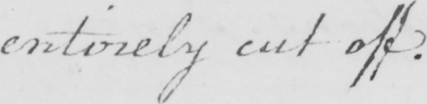Please transcribe the handwritten text in this image. entirely cut off. 